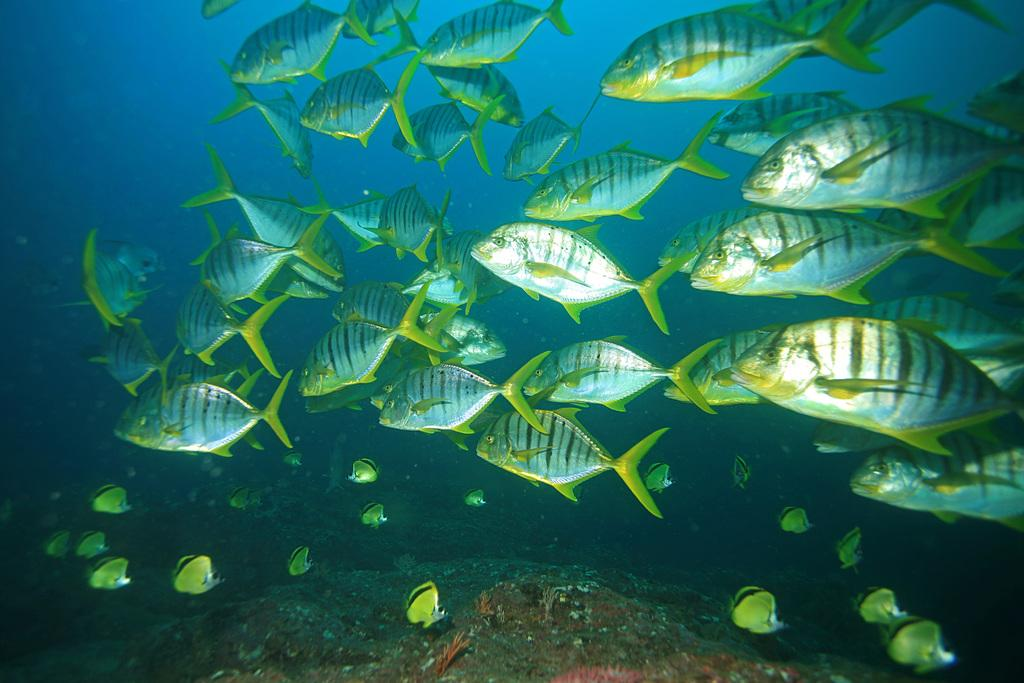What type of animals can be seen in the image? There are fishes in the image. What is the environment in which the fishes are located? The fishes and reefs are in water. What type of underwater structures are visible in the image? There are reefs in the image. What type of salt can be seen on the reefs in the image? There is no salt visible on the reefs in the image; it is an underwater scene with fishes and reefs in water. 